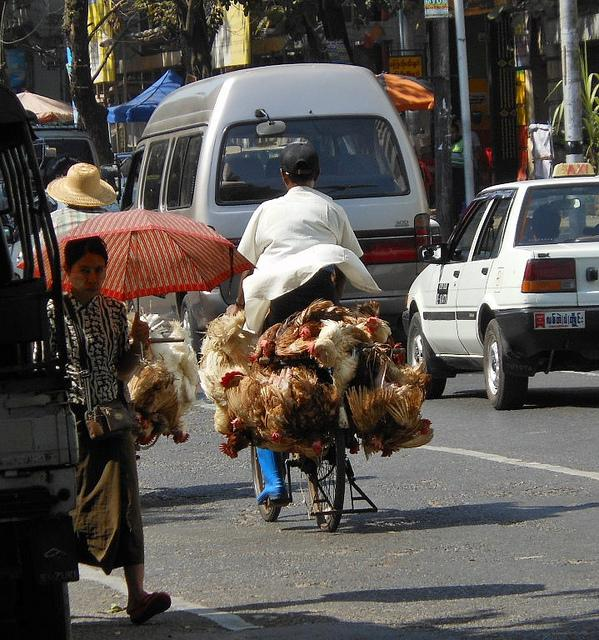What does the man on the bike do for a living?

Choices:
A) gives rides
B) sells bikes
C) sells chickens
D) steals bikes sells chickens 